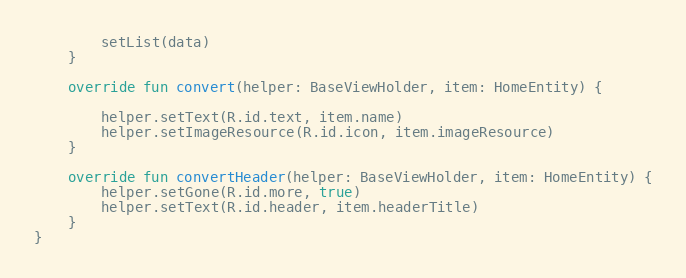<code> <loc_0><loc_0><loc_500><loc_500><_Kotlin_>        setList(data)
    }

    override fun convert(helper: BaseViewHolder, item: HomeEntity) {

        helper.setText(R.id.text, item.name)
        helper.setImageResource(R.id.icon, item.imageResource)
    }

    override fun convertHeader(helper: BaseViewHolder, item: HomeEntity) {
        helper.setGone(R.id.more, true)
        helper.setText(R.id.header, item.headerTitle)
    }
}</code> 